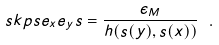Convert formula to latex. <formula><loc_0><loc_0><loc_500><loc_500>\ s k p s { e _ { x } } { e _ { y } } { s } = \frac { \epsilon _ { M } } { h ( s ( y ) , s ( x ) ) } \ .</formula> 